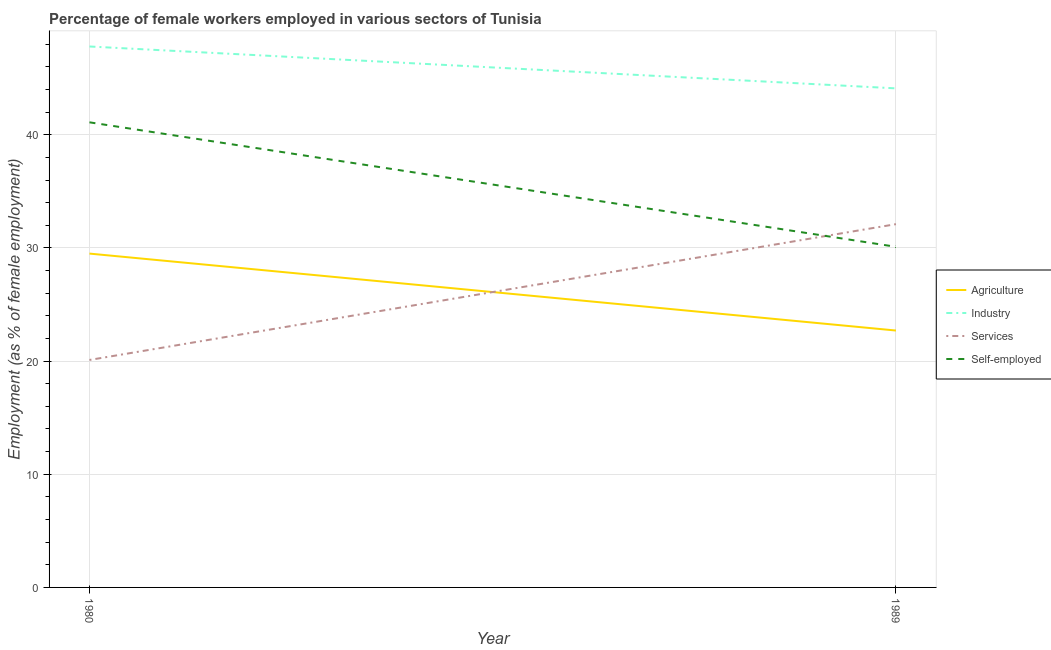Does the line corresponding to percentage of self employed female workers intersect with the line corresponding to percentage of female workers in agriculture?
Ensure brevity in your answer.  No. Is the number of lines equal to the number of legend labels?
Give a very brief answer. Yes. What is the percentage of female workers in industry in 1989?
Offer a very short reply. 44.1. Across all years, what is the maximum percentage of female workers in agriculture?
Provide a succinct answer. 29.5. Across all years, what is the minimum percentage of self employed female workers?
Your response must be concise. 30.1. In which year was the percentage of female workers in services maximum?
Offer a very short reply. 1989. What is the total percentage of female workers in industry in the graph?
Give a very brief answer. 91.9. What is the difference between the percentage of female workers in services in 1980 and that in 1989?
Ensure brevity in your answer.  -12. What is the difference between the percentage of female workers in agriculture in 1989 and the percentage of female workers in services in 1980?
Your answer should be very brief. 2.6. What is the average percentage of female workers in services per year?
Provide a succinct answer. 26.1. In the year 1989, what is the difference between the percentage of female workers in agriculture and percentage of female workers in services?
Provide a succinct answer. -9.4. In how many years, is the percentage of self employed female workers greater than 12 %?
Ensure brevity in your answer.  2. What is the ratio of the percentage of female workers in services in 1980 to that in 1989?
Offer a terse response. 0.63. Is it the case that in every year, the sum of the percentage of female workers in industry and percentage of female workers in services is greater than the sum of percentage of self employed female workers and percentage of female workers in agriculture?
Provide a succinct answer. Yes. Does the percentage of self employed female workers monotonically increase over the years?
Ensure brevity in your answer.  No. Is the percentage of self employed female workers strictly less than the percentage of female workers in services over the years?
Keep it short and to the point. No. Does the graph contain any zero values?
Make the answer very short. No. Does the graph contain grids?
Your answer should be very brief. Yes. Where does the legend appear in the graph?
Ensure brevity in your answer.  Center right. How are the legend labels stacked?
Provide a succinct answer. Vertical. What is the title of the graph?
Provide a succinct answer. Percentage of female workers employed in various sectors of Tunisia. Does "Management rating" appear as one of the legend labels in the graph?
Offer a terse response. No. What is the label or title of the X-axis?
Provide a short and direct response. Year. What is the label or title of the Y-axis?
Provide a succinct answer. Employment (as % of female employment). What is the Employment (as % of female employment) of Agriculture in 1980?
Keep it short and to the point. 29.5. What is the Employment (as % of female employment) of Industry in 1980?
Provide a short and direct response. 47.8. What is the Employment (as % of female employment) of Services in 1980?
Offer a very short reply. 20.1. What is the Employment (as % of female employment) in Self-employed in 1980?
Your answer should be very brief. 41.1. What is the Employment (as % of female employment) in Agriculture in 1989?
Your answer should be compact. 22.7. What is the Employment (as % of female employment) in Industry in 1989?
Give a very brief answer. 44.1. What is the Employment (as % of female employment) in Services in 1989?
Offer a terse response. 32.1. What is the Employment (as % of female employment) of Self-employed in 1989?
Provide a short and direct response. 30.1. Across all years, what is the maximum Employment (as % of female employment) of Agriculture?
Provide a short and direct response. 29.5. Across all years, what is the maximum Employment (as % of female employment) of Industry?
Keep it short and to the point. 47.8. Across all years, what is the maximum Employment (as % of female employment) in Services?
Provide a short and direct response. 32.1. Across all years, what is the maximum Employment (as % of female employment) of Self-employed?
Your answer should be very brief. 41.1. Across all years, what is the minimum Employment (as % of female employment) in Agriculture?
Offer a terse response. 22.7. Across all years, what is the minimum Employment (as % of female employment) in Industry?
Provide a short and direct response. 44.1. Across all years, what is the minimum Employment (as % of female employment) in Services?
Offer a terse response. 20.1. Across all years, what is the minimum Employment (as % of female employment) of Self-employed?
Offer a terse response. 30.1. What is the total Employment (as % of female employment) of Agriculture in the graph?
Ensure brevity in your answer.  52.2. What is the total Employment (as % of female employment) in Industry in the graph?
Your response must be concise. 91.9. What is the total Employment (as % of female employment) in Services in the graph?
Give a very brief answer. 52.2. What is the total Employment (as % of female employment) of Self-employed in the graph?
Your response must be concise. 71.2. What is the difference between the Employment (as % of female employment) in Agriculture in 1980 and that in 1989?
Make the answer very short. 6.8. What is the difference between the Employment (as % of female employment) in Agriculture in 1980 and the Employment (as % of female employment) in Industry in 1989?
Ensure brevity in your answer.  -14.6. What is the difference between the Employment (as % of female employment) of Agriculture in 1980 and the Employment (as % of female employment) of Services in 1989?
Keep it short and to the point. -2.6. What is the difference between the Employment (as % of female employment) of Agriculture in 1980 and the Employment (as % of female employment) of Self-employed in 1989?
Provide a short and direct response. -0.6. What is the difference between the Employment (as % of female employment) in Industry in 1980 and the Employment (as % of female employment) in Self-employed in 1989?
Your response must be concise. 17.7. What is the difference between the Employment (as % of female employment) of Services in 1980 and the Employment (as % of female employment) of Self-employed in 1989?
Your response must be concise. -10. What is the average Employment (as % of female employment) of Agriculture per year?
Make the answer very short. 26.1. What is the average Employment (as % of female employment) of Industry per year?
Provide a short and direct response. 45.95. What is the average Employment (as % of female employment) of Services per year?
Make the answer very short. 26.1. What is the average Employment (as % of female employment) in Self-employed per year?
Your answer should be very brief. 35.6. In the year 1980, what is the difference between the Employment (as % of female employment) in Agriculture and Employment (as % of female employment) in Industry?
Offer a terse response. -18.3. In the year 1980, what is the difference between the Employment (as % of female employment) of Agriculture and Employment (as % of female employment) of Self-employed?
Your response must be concise. -11.6. In the year 1980, what is the difference between the Employment (as % of female employment) in Industry and Employment (as % of female employment) in Services?
Keep it short and to the point. 27.7. In the year 1980, what is the difference between the Employment (as % of female employment) in Services and Employment (as % of female employment) in Self-employed?
Offer a terse response. -21. In the year 1989, what is the difference between the Employment (as % of female employment) in Agriculture and Employment (as % of female employment) in Industry?
Ensure brevity in your answer.  -21.4. In the year 1989, what is the difference between the Employment (as % of female employment) in Agriculture and Employment (as % of female employment) in Services?
Make the answer very short. -9.4. In the year 1989, what is the difference between the Employment (as % of female employment) in Agriculture and Employment (as % of female employment) in Self-employed?
Your response must be concise. -7.4. In the year 1989, what is the difference between the Employment (as % of female employment) of Services and Employment (as % of female employment) of Self-employed?
Provide a short and direct response. 2. What is the ratio of the Employment (as % of female employment) in Agriculture in 1980 to that in 1989?
Provide a succinct answer. 1.3. What is the ratio of the Employment (as % of female employment) of Industry in 1980 to that in 1989?
Ensure brevity in your answer.  1.08. What is the ratio of the Employment (as % of female employment) of Services in 1980 to that in 1989?
Offer a terse response. 0.63. What is the ratio of the Employment (as % of female employment) in Self-employed in 1980 to that in 1989?
Make the answer very short. 1.37. What is the difference between the highest and the second highest Employment (as % of female employment) in Industry?
Provide a succinct answer. 3.7. What is the difference between the highest and the second highest Employment (as % of female employment) of Services?
Give a very brief answer. 12. What is the difference between the highest and the second highest Employment (as % of female employment) of Self-employed?
Make the answer very short. 11. What is the difference between the highest and the lowest Employment (as % of female employment) of Industry?
Provide a short and direct response. 3.7. What is the difference between the highest and the lowest Employment (as % of female employment) of Self-employed?
Give a very brief answer. 11. 